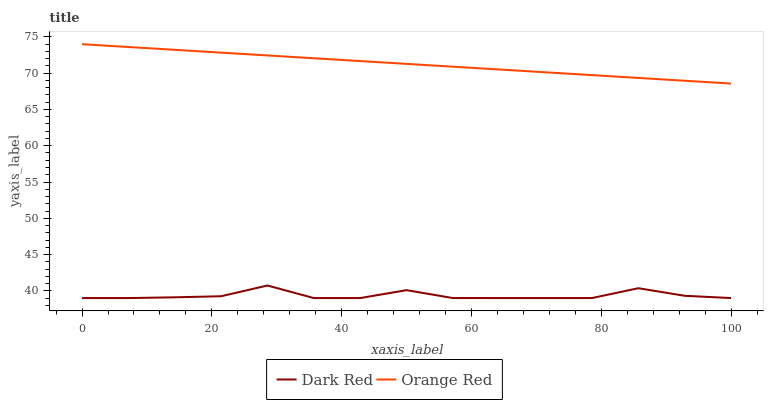Does Dark Red have the minimum area under the curve?
Answer yes or no. Yes. Does Orange Red have the maximum area under the curve?
Answer yes or no. Yes. Does Orange Red have the minimum area under the curve?
Answer yes or no. No. Is Orange Red the smoothest?
Answer yes or no. Yes. Is Dark Red the roughest?
Answer yes or no. Yes. Is Orange Red the roughest?
Answer yes or no. No. Does Dark Red have the lowest value?
Answer yes or no. Yes. Does Orange Red have the lowest value?
Answer yes or no. No. Does Orange Red have the highest value?
Answer yes or no. Yes. Is Dark Red less than Orange Red?
Answer yes or no. Yes. Is Orange Red greater than Dark Red?
Answer yes or no. Yes. Does Dark Red intersect Orange Red?
Answer yes or no. No. 